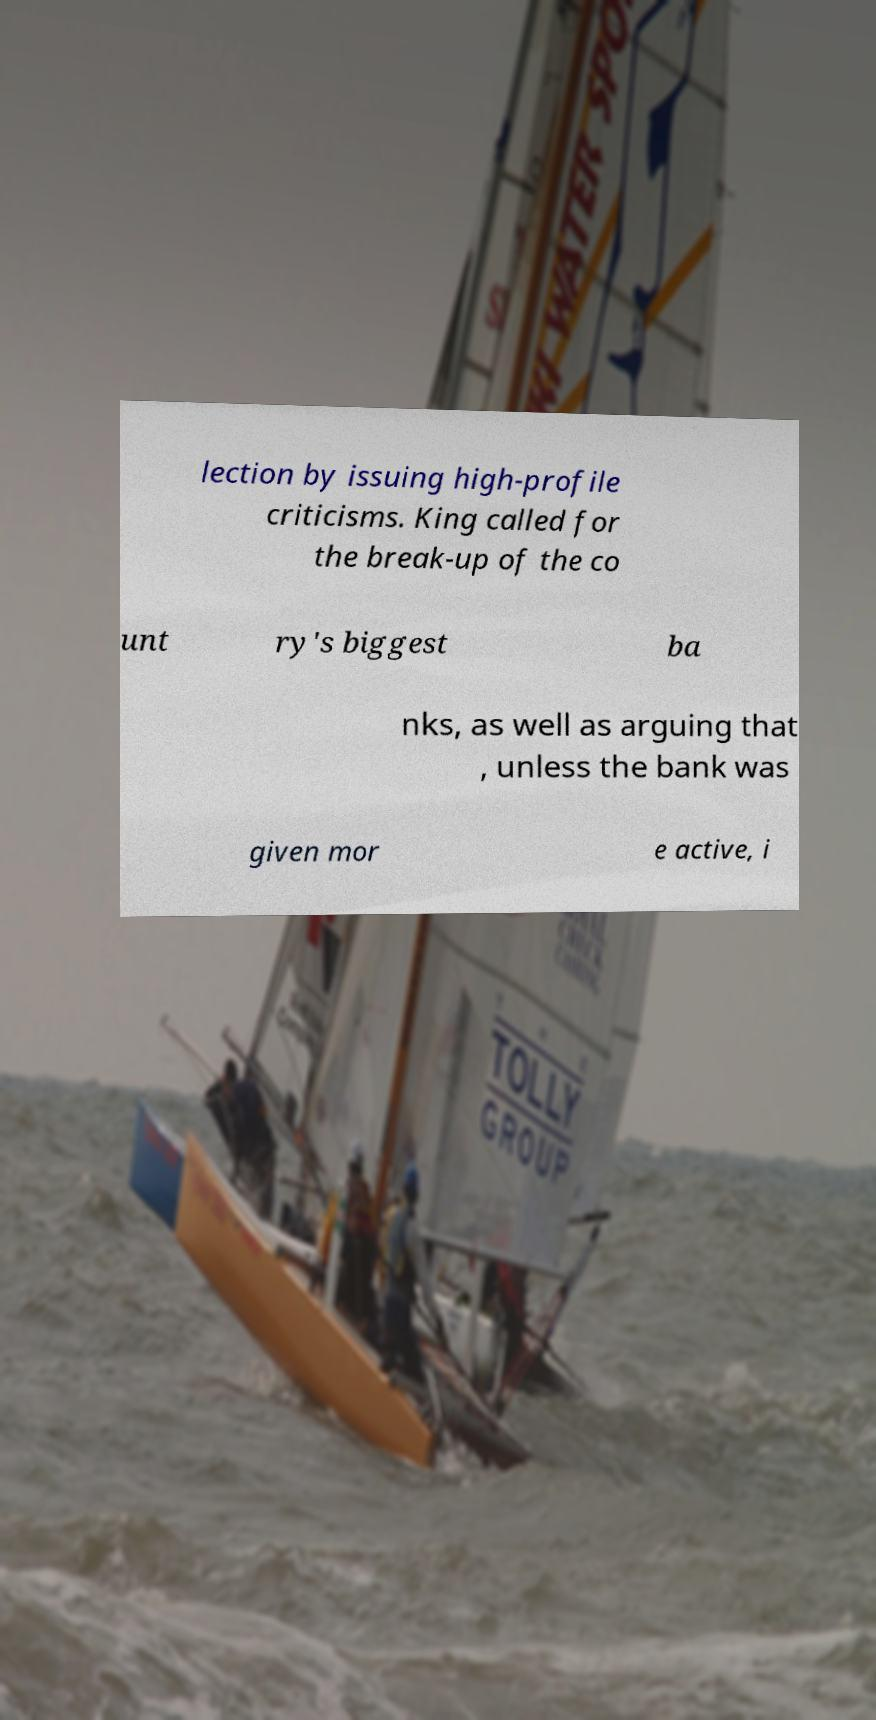Please identify and transcribe the text found in this image. lection by issuing high-profile criticisms. King called for the break-up of the co unt ry's biggest ba nks, as well as arguing that , unless the bank was given mor e active, i 